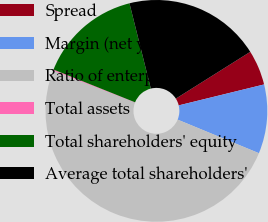Convert chart. <chart><loc_0><loc_0><loc_500><loc_500><pie_chart><fcel>Spread<fcel>Margin (net yield on<fcel>Ratio of enterprise<fcel>Total assets<fcel>Total shareholders' equity<fcel>Average total shareholders'<nl><fcel>5.11%<fcel>10.06%<fcel>49.69%<fcel>0.15%<fcel>15.02%<fcel>19.97%<nl></chart> 